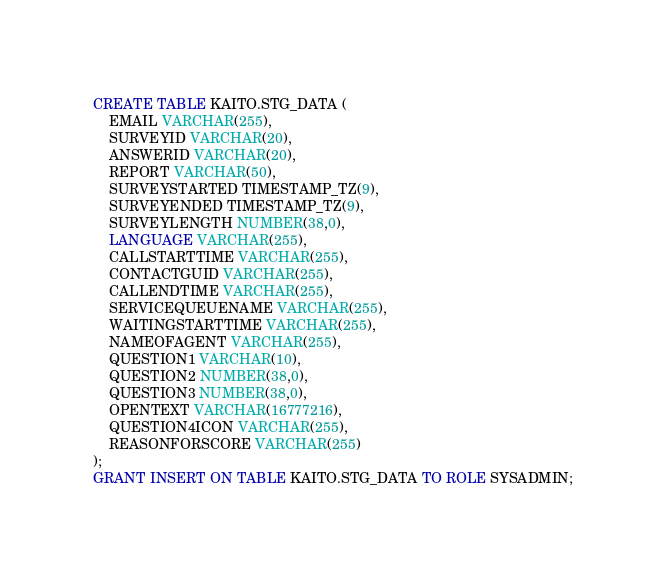<code> <loc_0><loc_0><loc_500><loc_500><_SQL_>
CREATE TABLE KAITO.STG_DATA (
	EMAIL VARCHAR(255),
	SURVEYID VARCHAR(20),
	ANSWERID VARCHAR(20),
	REPORT VARCHAR(50),
	SURVEYSTARTED TIMESTAMP_TZ(9),
	SURVEYENDED TIMESTAMP_TZ(9),
	SURVEYLENGTH NUMBER(38,0),
	LANGUAGE VARCHAR(255),
	CALLSTARTTIME VARCHAR(255),
	CONTACTGUID VARCHAR(255),
	CALLENDTIME VARCHAR(255),
	SERVICEQUEUENAME VARCHAR(255),
	WAITINGSTARTTIME VARCHAR(255),
	NAMEOFAGENT VARCHAR(255),
	QUESTION1 VARCHAR(10),
	QUESTION2 NUMBER(38,0),
	QUESTION3 NUMBER(38,0),
	OPENTEXT VARCHAR(16777216),
	QUESTION4ICON VARCHAR(255),
	REASONFORSCORE VARCHAR(255)
);
GRANT INSERT ON TABLE KAITO.STG_DATA TO ROLE SYSADMIN;</code> 